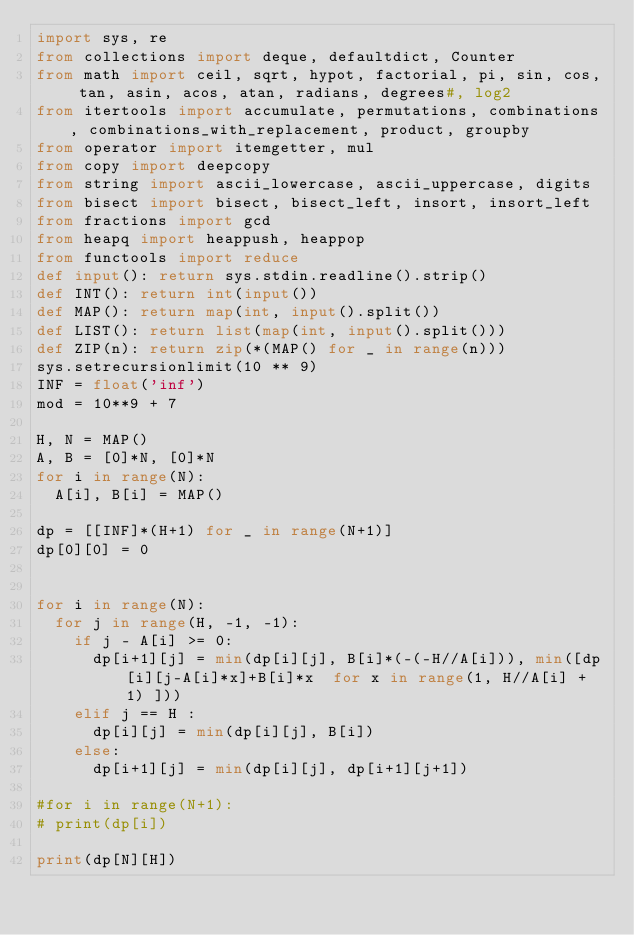<code> <loc_0><loc_0><loc_500><loc_500><_Python_>import sys, re
from collections import deque, defaultdict, Counter
from math import ceil, sqrt, hypot, factorial, pi, sin, cos, tan, asin, acos, atan, radians, degrees#, log2
from itertools import accumulate, permutations, combinations, combinations_with_replacement, product, groupby
from operator import itemgetter, mul
from copy import deepcopy
from string import ascii_lowercase, ascii_uppercase, digits
from bisect import bisect, bisect_left, insort, insort_left
from fractions import gcd
from heapq import heappush, heappop
from functools import reduce
def input(): return sys.stdin.readline().strip()
def INT(): return int(input())
def MAP(): return map(int, input().split())
def LIST(): return list(map(int, input().split()))
def ZIP(n): return zip(*(MAP() for _ in range(n)))
sys.setrecursionlimit(10 ** 9)
INF = float('inf')
mod = 10**9 + 7

H, N = MAP()
A, B = [0]*N, [0]*N
for i in range(N):
	A[i], B[i] = MAP()

dp = [[INF]*(H+1) for _ in range(N+1)]
dp[0][0] = 0


for i in range(N):
	for j in range(H, -1, -1):
		if j - A[i] >= 0:
			dp[i+1][j] = min(dp[i][j], B[i]*(-(-H//A[i])), min([dp[i][j-A[i]*x]+B[i]*x  for x in range(1, H//A[i] + 1) ]))
		elif j == H :
			dp[i][j] = min(dp[i][j], B[i])
		else:
			dp[i+1][j] = min(dp[i][j], dp[i+1][j+1])

#for i in range(N+1):
#	print(dp[i])

print(dp[N][H])





</code> 